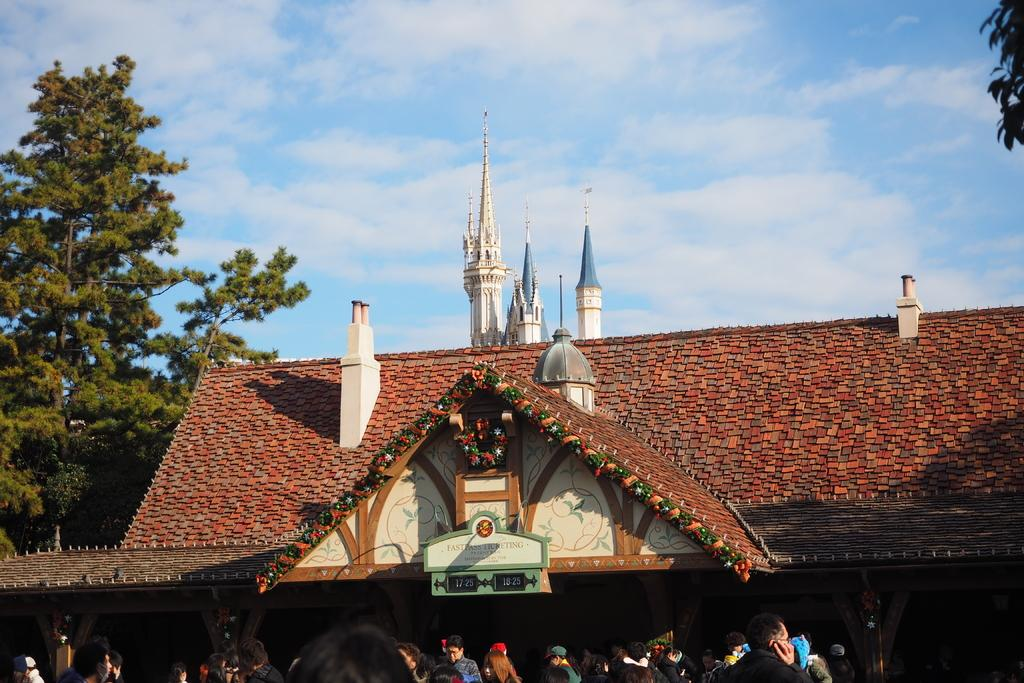What type of structure is visible in the image? There is a house roof in the image. What architectural elements can be seen in the image? There are pillars in the image. Are there any decorative items in the image? Yes, there are decorative items in the image. What is happening at the bottom of the image? There is a group of people at the bottom of the image. What can be seen in the background of the image? There are trees and the sky visible in the background of the image. What substance is being stretched by the people at the bottom of the image? There is no substance being stretched by the people at the bottom of the image. What is the value of the decorative items in the image? The value of the decorative items cannot be determined from the image alone. 